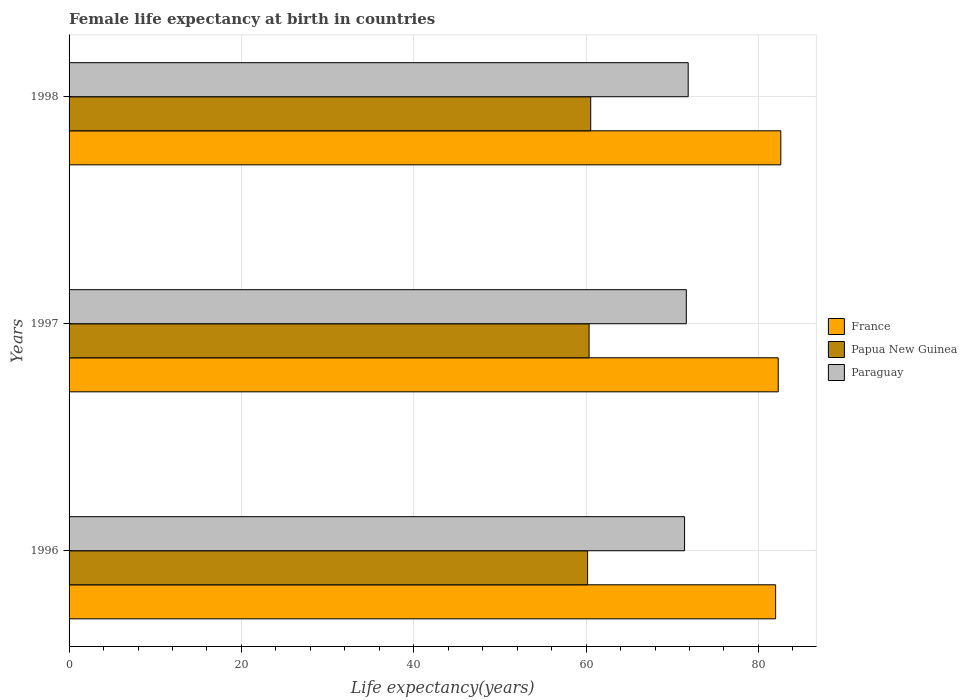How many different coloured bars are there?
Ensure brevity in your answer.  3. How many bars are there on the 3rd tick from the top?
Provide a succinct answer. 3. What is the label of the 1st group of bars from the top?
Offer a terse response. 1998. Across all years, what is the maximum female life expectancy at birth in Paraguay?
Offer a very short reply. 71.85. Across all years, what is the minimum female life expectancy at birth in Paraguay?
Offer a very short reply. 71.43. In which year was the female life expectancy at birth in Paraguay minimum?
Your answer should be very brief. 1996. What is the total female life expectancy at birth in France in the graph?
Your answer should be very brief. 246.9. What is the difference between the female life expectancy at birth in France in 1997 and that in 1998?
Your answer should be very brief. -0.3. What is the difference between the female life expectancy at birth in Paraguay in 1998 and the female life expectancy at birth in Papua New Guinea in 1997?
Make the answer very short. 11.5. What is the average female life expectancy at birth in France per year?
Offer a terse response. 82.3. In the year 1997, what is the difference between the female life expectancy at birth in Paraguay and female life expectancy at birth in Papua New Guinea?
Keep it short and to the point. 11.28. What is the ratio of the female life expectancy at birth in Paraguay in 1997 to that in 1998?
Offer a very short reply. 1. Is the difference between the female life expectancy at birth in Paraguay in 1996 and 1998 greater than the difference between the female life expectancy at birth in Papua New Guinea in 1996 and 1998?
Keep it short and to the point. No. What is the difference between the highest and the second highest female life expectancy at birth in Paraguay?
Provide a short and direct response. 0.22. What is the difference between the highest and the lowest female life expectancy at birth in Papua New Guinea?
Provide a succinct answer. 0.36. In how many years, is the female life expectancy at birth in Papua New Guinea greater than the average female life expectancy at birth in Papua New Guinea taken over all years?
Your answer should be compact. 1. Is the sum of the female life expectancy at birth in France in 1996 and 1997 greater than the maximum female life expectancy at birth in Paraguay across all years?
Provide a succinct answer. Yes. What does the 1st bar from the top in 1997 represents?
Provide a short and direct response. Paraguay. Is it the case that in every year, the sum of the female life expectancy at birth in Papua New Guinea and female life expectancy at birth in Paraguay is greater than the female life expectancy at birth in France?
Make the answer very short. Yes. How many bars are there?
Your answer should be very brief. 9. Are all the bars in the graph horizontal?
Provide a succinct answer. Yes. Does the graph contain any zero values?
Your response must be concise. No. Does the graph contain grids?
Make the answer very short. Yes. What is the title of the graph?
Offer a very short reply. Female life expectancy at birth in countries. Does "Barbados" appear as one of the legend labels in the graph?
Your response must be concise. No. What is the label or title of the X-axis?
Your response must be concise. Life expectancy(years). What is the Life expectancy(years) of Papua New Guinea in 1996?
Your response must be concise. 60.18. What is the Life expectancy(years) in Paraguay in 1996?
Offer a very short reply. 71.43. What is the Life expectancy(years) in France in 1997?
Provide a succinct answer. 82.3. What is the Life expectancy(years) in Papua New Guinea in 1997?
Ensure brevity in your answer.  60.35. What is the Life expectancy(years) in Paraguay in 1997?
Keep it short and to the point. 71.64. What is the Life expectancy(years) in France in 1998?
Your answer should be very brief. 82.6. What is the Life expectancy(years) in Papua New Guinea in 1998?
Provide a succinct answer. 60.54. What is the Life expectancy(years) of Paraguay in 1998?
Offer a very short reply. 71.85. Across all years, what is the maximum Life expectancy(years) in France?
Offer a very short reply. 82.6. Across all years, what is the maximum Life expectancy(years) in Papua New Guinea?
Your answer should be compact. 60.54. Across all years, what is the maximum Life expectancy(years) of Paraguay?
Your answer should be very brief. 71.85. Across all years, what is the minimum Life expectancy(years) in France?
Provide a short and direct response. 82. Across all years, what is the minimum Life expectancy(years) in Papua New Guinea?
Your answer should be compact. 60.18. Across all years, what is the minimum Life expectancy(years) of Paraguay?
Give a very brief answer. 71.43. What is the total Life expectancy(years) of France in the graph?
Offer a terse response. 246.9. What is the total Life expectancy(years) of Papua New Guinea in the graph?
Keep it short and to the point. 181.07. What is the total Life expectancy(years) of Paraguay in the graph?
Your answer should be very brief. 214.92. What is the difference between the Life expectancy(years) in France in 1996 and that in 1997?
Keep it short and to the point. -0.3. What is the difference between the Life expectancy(years) of Papua New Guinea in 1996 and that in 1997?
Ensure brevity in your answer.  -0.17. What is the difference between the Life expectancy(years) of Paraguay in 1996 and that in 1997?
Provide a succinct answer. -0.2. What is the difference between the Life expectancy(years) in Papua New Guinea in 1996 and that in 1998?
Your response must be concise. -0.36. What is the difference between the Life expectancy(years) of Paraguay in 1996 and that in 1998?
Your answer should be very brief. -0.42. What is the difference between the Life expectancy(years) of Papua New Guinea in 1997 and that in 1998?
Give a very brief answer. -0.19. What is the difference between the Life expectancy(years) of Paraguay in 1997 and that in 1998?
Your response must be concise. -0.22. What is the difference between the Life expectancy(years) of France in 1996 and the Life expectancy(years) of Papua New Guinea in 1997?
Make the answer very short. 21.65. What is the difference between the Life expectancy(years) of France in 1996 and the Life expectancy(years) of Paraguay in 1997?
Provide a short and direct response. 10.37. What is the difference between the Life expectancy(years) in Papua New Guinea in 1996 and the Life expectancy(years) in Paraguay in 1997?
Give a very brief answer. -11.46. What is the difference between the Life expectancy(years) of France in 1996 and the Life expectancy(years) of Papua New Guinea in 1998?
Offer a terse response. 21.46. What is the difference between the Life expectancy(years) in France in 1996 and the Life expectancy(years) in Paraguay in 1998?
Ensure brevity in your answer.  10.15. What is the difference between the Life expectancy(years) of Papua New Guinea in 1996 and the Life expectancy(years) of Paraguay in 1998?
Offer a terse response. -11.67. What is the difference between the Life expectancy(years) of France in 1997 and the Life expectancy(years) of Papua New Guinea in 1998?
Ensure brevity in your answer.  21.76. What is the difference between the Life expectancy(years) of France in 1997 and the Life expectancy(years) of Paraguay in 1998?
Provide a succinct answer. 10.45. What is the difference between the Life expectancy(years) of Papua New Guinea in 1997 and the Life expectancy(years) of Paraguay in 1998?
Your answer should be compact. -11.5. What is the average Life expectancy(years) in France per year?
Provide a succinct answer. 82.3. What is the average Life expectancy(years) in Papua New Guinea per year?
Provide a short and direct response. 60.36. What is the average Life expectancy(years) of Paraguay per year?
Offer a terse response. 71.64. In the year 1996, what is the difference between the Life expectancy(years) in France and Life expectancy(years) in Papua New Guinea?
Provide a short and direct response. 21.82. In the year 1996, what is the difference between the Life expectancy(years) in France and Life expectancy(years) in Paraguay?
Ensure brevity in your answer.  10.57. In the year 1996, what is the difference between the Life expectancy(years) in Papua New Guinea and Life expectancy(years) in Paraguay?
Your response must be concise. -11.25. In the year 1997, what is the difference between the Life expectancy(years) in France and Life expectancy(years) in Papua New Guinea?
Provide a succinct answer. 21.95. In the year 1997, what is the difference between the Life expectancy(years) in France and Life expectancy(years) in Paraguay?
Keep it short and to the point. 10.66. In the year 1997, what is the difference between the Life expectancy(years) in Papua New Guinea and Life expectancy(years) in Paraguay?
Ensure brevity in your answer.  -11.28. In the year 1998, what is the difference between the Life expectancy(years) of France and Life expectancy(years) of Papua New Guinea?
Offer a terse response. 22.06. In the year 1998, what is the difference between the Life expectancy(years) of France and Life expectancy(years) of Paraguay?
Offer a very short reply. 10.75. In the year 1998, what is the difference between the Life expectancy(years) in Papua New Guinea and Life expectancy(years) in Paraguay?
Keep it short and to the point. -11.31. What is the ratio of the Life expectancy(years) of France in 1996 to that in 1997?
Your response must be concise. 1. What is the ratio of the Life expectancy(years) in Papua New Guinea in 1996 to that in 1997?
Make the answer very short. 1. What is the ratio of the Life expectancy(years) in France in 1996 to that in 1998?
Make the answer very short. 0.99. What is the ratio of the Life expectancy(years) in Papua New Guinea in 1996 to that in 1998?
Your answer should be compact. 0.99. What is the ratio of the Life expectancy(years) of Paraguay in 1997 to that in 1998?
Ensure brevity in your answer.  1. What is the difference between the highest and the second highest Life expectancy(years) of France?
Your answer should be very brief. 0.3. What is the difference between the highest and the second highest Life expectancy(years) in Papua New Guinea?
Ensure brevity in your answer.  0.19. What is the difference between the highest and the second highest Life expectancy(years) in Paraguay?
Provide a succinct answer. 0.22. What is the difference between the highest and the lowest Life expectancy(years) in Papua New Guinea?
Your response must be concise. 0.36. What is the difference between the highest and the lowest Life expectancy(years) of Paraguay?
Offer a terse response. 0.42. 